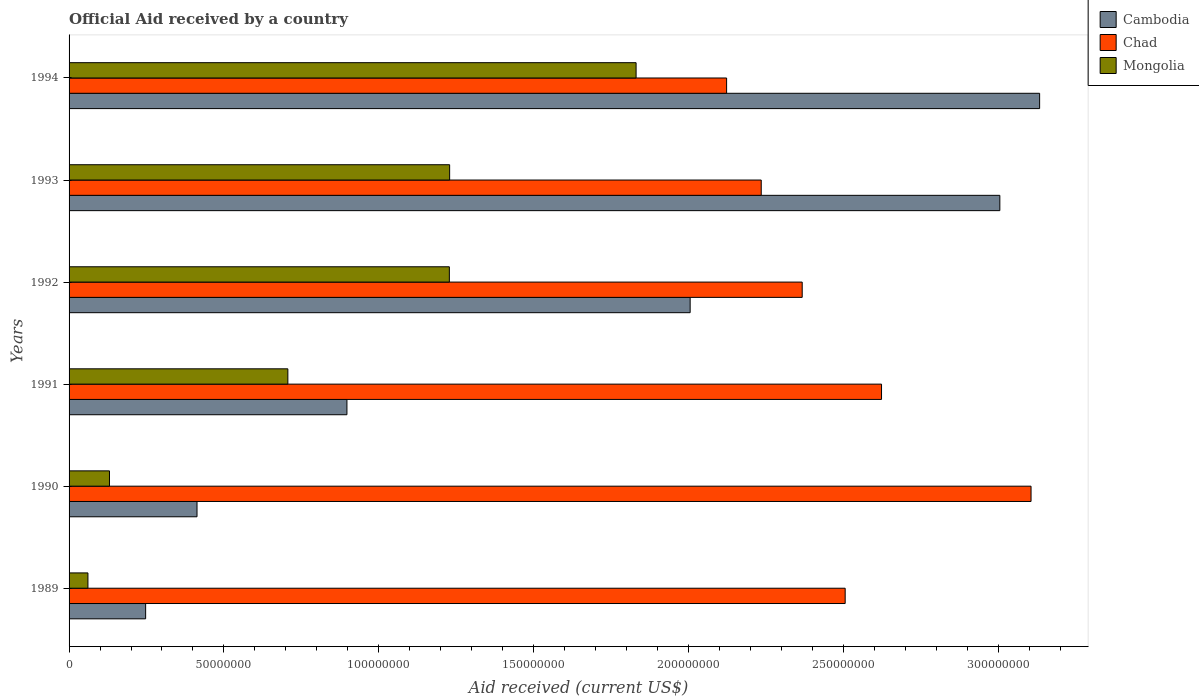How many different coloured bars are there?
Your answer should be very brief. 3. Are the number of bars per tick equal to the number of legend labels?
Keep it short and to the point. Yes. Are the number of bars on each tick of the Y-axis equal?
Make the answer very short. Yes. How many bars are there on the 1st tick from the bottom?
Your response must be concise. 3. What is the label of the 3rd group of bars from the top?
Make the answer very short. 1992. In how many cases, is the number of bars for a given year not equal to the number of legend labels?
Your answer should be compact. 0. What is the net official aid received in Cambodia in 1994?
Offer a terse response. 3.13e+08. Across all years, what is the maximum net official aid received in Cambodia?
Offer a very short reply. 3.13e+08. Across all years, what is the minimum net official aid received in Chad?
Provide a succinct answer. 2.12e+08. In which year was the net official aid received in Chad maximum?
Offer a terse response. 1990. What is the total net official aid received in Mongolia in the graph?
Your response must be concise. 5.18e+08. What is the difference between the net official aid received in Cambodia in 1991 and that in 1993?
Provide a short and direct response. -2.11e+08. What is the difference between the net official aid received in Mongolia in 1992 and the net official aid received in Cambodia in 1994?
Your response must be concise. -1.91e+08. What is the average net official aid received in Chad per year?
Ensure brevity in your answer.  2.49e+08. In the year 1990, what is the difference between the net official aid received in Chad and net official aid received in Mongolia?
Ensure brevity in your answer.  2.98e+08. In how many years, is the net official aid received in Chad greater than 70000000 US$?
Your answer should be compact. 6. What is the ratio of the net official aid received in Cambodia in 1990 to that in 1991?
Provide a short and direct response. 0.46. Is the difference between the net official aid received in Chad in 1989 and 1994 greater than the difference between the net official aid received in Mongolia in 1989 and 1994?
Provide a short and direct response. Yes. What is the difference between the highest and the second highest net official aid received in Mongolia?
Your answer should be very brief. 6.02e+07. What is the difference between the highest and the lowest net official aid received in Chad?
Your answer should be very brief. 9.83e+07. What does the 2nd bar from the top in 1992 represents?
Your response must be concise. Chad. What does the 1st bar from the bottom in 1991 represents?
Your answer should be very brief. Cambodia. Is it the case that in every year, the sum of the net official aid received in Mongolia and net official aid received in Cambodia is greater than the net official aid received in Chad?
Offer a terse response. No. How many years are there in the graph?
Offer a terse response. 6. What is the difference between two consecutive major ticks on the X-axis?
Your answer should be very brief. 5.00e+07. Are the values on the major ticks of X-axis written in scientific E-notation?
Give a very brief answer. No. Does the graph contain any zero values?
Make the answer very short. No. Does the graph contain grids?
Offer a terse response. No. What is the title of the graph?
Offer a terse response. Official Aid received by a country. What is the label or title of the X-axis?
Keep it short and to the point. Aid received (current US$). What is the Aid received (current US$) in Cambodia in 1989?
Offer a very short reply. 2.47e+07. What is the Aid received (current US$) of Chad in 1989?
Your answer should be compact. 2.51e+08. What is the Aid received (current US$) in Mongolia in 1989?
Provide a succinct answer. 6.09e+06. What is the Aid received (current US$) of Cambodia in 1990?
Give a very brief answer. 4.13e+07. What is the Aid received (current US$) of Chad in 1990?
Your response must be concise. 3.11e+08. What is the Aid received (current US$) of Mongolia in 1990?
Make the answer very short. 1.30e+07. What is the Aid received (current US$) of Cambodia in 1991?
Make the answer very short. 8.97e+07. What is the Aid received (current US$) of Chad in 1991?
Provide a succinct answer. 2.62e+08. What is the Aid received (current US$) in Mongolia in 1991?
Your answer should be very brief. 7.06e+07. What is the Aid received (current US$) in Cambodia in 1992?
Your response must be concise. 2.01e+08. What is the Aid received (current US$) in Chad in 1992?
Ensure brevity in your answer.  2.37e+08. What is the Aid received (current US$) in Mongolia in 1992?
Keep it short and to the point. 1.23e+08. What is the Aid received (current US$) of Cambodia in 1993?
Keep it short and to the point. 3.01e+08. What is the Aid received (current US$) of Chad in 1993?
Your response must be concise. 2.23e+08. What is the Aid received (current US$) of Mongolia in 1993?
Your answer should be very brief. 1.23e+08. What is the Aid received (current US$) in Cambodia in 1994?
Provide a short and direct response. 3.13e+08. What is the Aid received (current US$) of Chad in 1994?
Your answer should be compact. 2.12e+08. What is the Aid received (current US$) of Mongolia in 1994?
Make the answer very short. 1.83e+08. Across all years, what is the maximum Aid received (current US$) of Cambodia?
Keep it short and to the point. 3.13e+08. Across all years, what is the maximum Aid received (current US$) in Chad?
Offer a very short reply. 3.11e+08. Across all years, what is the maximum Aid received (current US$) in Mongolia?
Give a very brief answer. 1.83e+08. Across all years, what is the minimum Aid received (current US$) of Cambodia?
Give a very brief answer. 2.47e+07. Across all years, what is the minimum Aid received (current US$) of Chad?
Ensure brevity in your answer.  2.12e+08. Across all years, what is the minimum Aid received (current US$) of Mongolia?
Keep it short and to the point. 6.09e+06. What is the total Aid received (current US$) of Cambodia in the graph?
Offer a terse response. 9.70e+08. What is the total Aid received (current US$) in Chad in the graph?
Give a very brief answer. 1.50e+09. What is the total Aid received (current US$) in Mongolia in the graph?
Give a very brief answer. 5.18e+08. What is the difference between the Aid received (current US$) of Cambodia in 1989 and that in 1990?
Your answer should be compact. -1.66e+07. What is the difference between the Aid received (current US$) of Chad in 1989 and that in 1990?
Give a very brief answer. -6.00e+07. What is the difference between the Aid received (current US$) of Mongolia in 1989 and that in 1990?
Give a very brief answer. -6.96e+06. What is the difference between the Aid received (current US$) of Cambodia in 1989 and that in 1991?
Offer a very short reply. -6.50e+07. What is the difference between the Aid received (current US$) of Chad in 1989 and that in 1991?
Make the answer very short. -1.17e+07. What is the difference between the Aid received (current US$) in Mongolia in 1989 and that in 1991?
Provide a succinct answer. -6.46e+07. What is the difference between the Aid received (current US$) in Cambodia in 1989 and that in 1992?
Your response must be concise. -1.76e+08. What is the difference between the Aid received (current US$) of Chad in 1989 and that in 1992?
Your response must be concise. 1.39e+07. What is the difference between the Aid received (current US$) of Mongolia in 1989 and that in 1992?
Offer a very short reply. -1.17e+08. What is the difference between the Aid received (current US$) of Cambodia in 1989 and that in 1993?
Keep it short and to the point. -2.76e+08. What is the difference between the Aid received (current US$) of Chad in 1989 and that in 1993?
Your response must be concise. 2.71e+07. What is the difference between the Aid received (current US$) in Mongolia in 1989 and that in 1993?
Give a very brief answer. -1.17e+08. What is the difference between the Aid received (current US$) of Cambodia in 1989 and that in 1994?
Your answer should be very brief. -2.89e+08. What is the difference between the Aid received (current US$) of Chad in 1989 and that in 1994?
Keep it short and to the point. 3.83e+07. What is the difference between the Aid received (current US$) of Mongolia in 1989 and that in 1994?
Offer a very short reply. -1.77e+08. What is the difference between the Aid received (current US$) in Cambodia in 1990 and that in 1991?
Keep it short and to the point. -4.84e+07. What is the difference between the Aid received (current US$) of Chad in 1990 and that in 1991?
Provide a succinct answer. 4.83e+07. What is the difference between the Aid received (current US$) of Mongolia in 1990 and that in 1991?
Keep it short and to the point. -5.76e+07. What is the difference between the Aid received (current US$) of Cambodia in 1990 and that in 1992?
Ensure brevity in your answer.  -1.59e+08. What is the difference between the Aid received (current US$) of Chad in 1990 and that in 1992?
Offer a terse response. 7.39e+07. What is the difference between the Aid received (current US$) of Mongolia in 1990 and that in 1992?
Offer a terse response. -1.10e+08. What is the difference between the Aid received (current US$) of Cambodia in 1990 and that in 1993?
Offer a terse response. -2.59e+08. What is the difference between the Aid received (current US$) of Chad in 1990 and that in 1993?
Keep it short and to the point. 8.71e+07. What is the difference between the Aid received (current US$) of Mongolia in 1990 and that in 1993?
Provide a succinct answer. -1.10e+08. What is the difference between the Aid received (current US$) in Cambodia in 1990 and that in 1994?
Offer a very short reply. -2.72e+08. What is the difference between the Aid received (current US$) of Chad in 1990 and that in 1994?
Your response must be concise. 9.83e+07. What is the difference between the Aid received (current US$) of Mongolia in 1990 and that in 1994?
Make the answer very short. -1.70e+08. What is the difference between the Aid received (current US$) of Cambodia in 1991 and that in 1992?
Your answer should be very brief. -1.11e+08. What is the difference between the Aid received (current US$) of Chad in 1991 and that in 1992?
Keep it short and to the point. 2.56e+07. What is the difference between the Aid received (current US$) in Mongolia in 1991 and that in 1992?
Your response must be concise. -5.21e+07. What is the difference between the Aid received (current US$) in Cambodia in 1991 and that in 1993?
Your answer should be very brief. -2.11e+08. What is the difference between the Aid received (current US$) of Chad in 1991 and that in 1993?
Ensure brevity in your answer.  3.88e+07. What is the difference between the Aid received (current US$) in Mongolia in 1991 and that in 1993?
Ensure brevity in your answer.  -5.22e+07. What is the difference between the Aid received (current US$) of Cambodia in 1991 and that in 1994?
Make the answer very short. -2.24e+08. What is the difference between the Aid received (current US$) in Chad in 1991 and that in 1994?
Ensure brevity in your answer.  5.00e+07. What is the difference between the Aid received (current US$) in Mongolia in 1991 and that in 1994?
Your answer should be very brief. -1.12e+08. What is the difference between the Aid received (current US$) in Cambodia in 1992 and that in 1993?
Give a very brief answer. -1.00e+08. What is the difference between the Aid received (current US$) in Chad in 1992 and that in 1993?
Provide a short and direct response. 1.32e+07. What is the difference between the Aid received (current US$) in Cambodia in 1992 and that in 1994?
Your response must be concise. -1.13e+08. What is the difference between the Aid received (current US$) of Chad in 1992 and that in 1994?
Ensure brevity in your answer.  2.44e+07. What is the difference between the Aid received (current US$) of Mongolia in 1992 and that in 1994?
Give a very brief answer. -6.03e+07. What is the difference between the Aid received (current US$) in Cambodia in 1993 and that in 1994?
Ensure brevity in your answer.  -1.28e+07. What is the difference between the Aid received (current US$) of Chad in 1993 and that in 1994?
Offer a terse response. 1.12e+07. What is the difference between the Aid received (current US$) of Mongolia in 1993 and that in 1994?
Your response must be concise. -6.02e+07. What is the difference between the Aid received (current US$) of Cambodia in 1989 and the Aid received (current US$) of Chad in 1990?
Offer a terse response. -2.86e+08. What is the difference between the Aid received (current US$) of Cambodia in 1989 and the Aid received (current US$) of Mongolia in 1990?
Provide a succinct answer. 1.17e+07. What is the difference between the Aid received (current US$) of Chad in 1989 and the Aid received (current US$) of Mongolia in 1990?
Keep it short and to the point. 2.38e+08. What is the difference between the Aid received (current US$) of Cambodia in 1989 and the Aid received (current US$) of Chad in 1991?
Ensure brevity in your answer.  -2.38e+08. What is the difference between the Aid received (current US$) of Cambodia in 1989 and the Aid received (current US$) of Mongolia in 1991?
Your answer should be very brief. -4.59e+07. What is the difference between the Aid received (current US$) of Chad in 1989 and the Aid received (current US$) of Mongolia in 1991?
Offer a terse response. 1.80e+08. What is the difference between the Aid received (current US$) in Cambodia in 1989 and the Aid received (current US$) in Chad in 1992?
Your response must be concise. -2.12e+08. What is the difference between the Aid received (current US$) in Cambodia in 1989 and the Aid received (current US$) in Mongolia in 1992?
Your answer should be compact. -9.81e+07. What is the difference between the Aid received (current US$) of Chad in 1989 and the Aid received (current US$) of Mongolia in 1992?
Make the answer very short. 1.28e+08. What is the difference between the Aid received (current US$) of Cambodia in 1989 and the Aid received (current US$) of Chad in 1993?
Keep it short and to the point. -1.99e+08. What is the difference between the Aid received (current US$) in Cambodia in 1989 and the Aid received (current US$) in Mongolia in 1993?
Ensure brevity in your answer.  -9.82e+07. What is the difference between the Aid received (current US$) in Chad in 1989 and the Aid received (current US$) in Mongolia in 1993?
Make the answer very short. 1.28e+08. What is the difference between the Aid received (current US$) in Cambodia in 1989 and the Aid received (current US$) in Chad in 1994?
Make the answer very short. -1.88e+08. What is the difference between the Aid received (current US$) of Cambodia in 1989 and the Aid received (current US$) of Mongolia in 1994?
Keep it short and to the point. -1.58e+08. What is the difference between the Aid received (current US$) of Chad in 1989 and the Aid received (current US$) of Mongolia in 1994?
Give a very brief answer. 6.75e+07. What is the difference between the Aid received (current US$) in Cambodia in 1990 and the Aid received (current US$) in Chad in 1991?
Your response must be concise. -2.21e+08. What is the difference between the Aid received (current US$) of Cambodia in 1990 and the Aid received (current US$) of Mongolia in 1991?
Make the answer very short. -2.93e+07. What is the difference between the Aid received (current US$) in Chad in 1990 and the Aid received (current US$) in Mongolia in 1991?
Keep it short and to the point. 2.40e+08. What is the difference between the Aid received (current US$) of Cambodia in 1990 and the Aid received (current US$) of Chad in 1992?
Keep it short and to the point. -1.95e+08. What is the difference between the Aid received (current US$) of Cambodia in 1990 and the Aid received (current US$) of Mongolia in 1992?
Ensure brevity in your answer.  -8.15e+07. What is the difference between the Aid received (current US$) of Chad in 1990 and the Aid received (current US$) of Mongolia in 1992?
Offer a very short reply. 1.88e+08. What is the difference between the Aid received (current US$) of Cambodia in 1990 and the Aid received (current US$) of Chad in 1993?
Ensure brevity in your answer.  -1.82e+08. What is the difference between the Aid received (current US$) in Cambodia in 1990 and the Aid received (current US$) in Mongolia in 1993?
Offer a very short reply. -8.16e+07. What is the difference between the Aid received (current US$) of Chad in 1990 and the Aid received (current US$) of Mongolia in 1993?
Offer a terse response. 1.88e+08. What is the difference between the Aid received (current US$) in Cambodia in 1990 and the Aid received (current US$) in Chad in 1994?
Give a very brief answer. -1.71e+08. What is the difference between the Aid received (current US$) in Cambodia in 1990 and the Aid received (current US$) in Mongolia in 1994?
Give a very brief answer. -1.42e+08. What is the difference between the Aid received (current US$) of Chad in 1990 and the Aid received (current US$) of Mongolia in 1994?
Your answer should be compact. 1.28e+08. What is the difference between the Aid received (current US$) in Cambodia in 1991 and the Aid received (current US$) in Chad in 1992?
Make the answer very short. -1.47e+08. What is the difference between the Aid received (current US$) of Cambodia in 1991 and the Aid received (current US$) of Mongolia in 1992?
Give a very brief answer. -3.31e+07. What is the difference between the Aid received (current US$) of Chad in 1991 and the Aid received (current US$) of Mongolia in 1992?
Give a very brief answer. 1.40e+08. What is the difference between the Aid received (current US$) in Cambodia in 1991 and the Aid received (current US$) in Chad in 1993?
Give a very brief answer. -1.34e+08. What is the difference between the Aid received (current US$) of Cambodia in 1991 and the Aid received (current US$) of Mongolia in 1993?
Your answer should be very brief. -3.32e+07. What is the difference between the Aid received (current US$) in Chad in 1991 and the Aid received (current US$) in Mongolia in 1993?
Keep it short and to the point. 1.39e+08. What is the difference between the Aid received (current US$) in Cambodia in 1991 and the Aid received (current US$) in Chad in 1994?
Provide a short and direct response. -1.23e+08. What is the difference between the Aid received (current US$) in Cambodia in 1991 and the Aid received (current US$) in Mongolia in 1994?
Provide a succinct answer. -9.34e+07. What is the difference between the Aid received (current US$) in Chad in 1991 and the Aid received (current US$) in Mongolia in 1994?
Keep it short and to the point. 7.92e+07. What is the difference between the Aid received (current US$) in Cambodia in 1992 and the Aid received (current US$) in Chad in 1993?
Offer a very short reply. -2.30e+07. What is the difference between the Aid received (current US$) in Cambodia in 1992 and the Aid received (current US$) in Mongolia in 1993?
Your response must be concise. 7.76e+07. What is the difference between the Aid received (current US$) in Chad in 1992 and the Aid received (current US$) in Mongolia in 1993?
Your answer should be compact. 1.14e+08. What is the difference between the Aid received (current US$) in Cambodia in 1992 and the Aid received (current US$) in Chad in 1994?
Give a very brief answer. -1.18e+07. What is the difference between the Aid received (current US$) of Cambodia in 1992 and the Aid received (current US$) of Mongolia in 1994?
Your response must be concise. 1.74e+07. What is the difference between the Aid received (current US$) in Chad in 1992 and the Aid received (current US$) in Mongolia in 1994?
Provide a short and direct response. 5.36e+07. What is the difference between the Aid received (current US$) in Cambodia in 1993 and the Aid received (current US$) in Chad in 1994?
Your response must be concise. 8.82e+07. What is the difference between the Aid received (current US$) of Cambodia in 1993 and the Aid received (current US$) of Mongolia in 1994?
Ensure brevity in your answer.  1.17e+08. What is the difference between the Aid received (current US$) of Chad in 1993 and the Aid received (current US$) of Mongolia in 1994?
Offer a very short reply. 4.04e+07. What is the average Aid received (current US$) in Cambodia per year?
Your answer should be compact. 1.62e+08. What is the average Aid received (current US$) of Chad per year?
Make the answer very short. 2.49e+08. What is the average Aid received (current US$) in Mongolia per year?
Your answer should be compact. 8.64e+07. In the year 1989, what is the difference between the Aid received (current US$) in Cambodia and Aid received (current US$) in Chad?
Offer a terse response. -2.26e+08. In the year 1989, what is the difference between the Aid received (current US$) in Cambodia and Aid received (current US$) in Mongolia?
Offer a terse response. 1.86e+07. In the year 1989, what is the difference between the Aid received (current US$) in Chad and Aid received (current US$) in Mongolia?
Your response must be concise. 2.44e+08. In the year 1990, what is the difference between the Aid received (current US$) in Cambodia and Aid received (current US$) in Chad?
Offer a very short reply. -2.69e+08. In the year 1990, what is the difference between the Aid received (current US$) in Cambodia and Aid received (current US$) in Mongolia?
Your answer should be compact. 2.83e+07. In the year 1990, what is the difference between the Aid received (current US$) in Chad and Aid received (current US$) in Mongolia?
Provide a short and direct response. 2.98e+08. In the year 1991, what is the difference between the Aid received (current US$) in Cambodia and Aid received (current US$) in Chad?
Your answer should be very brief. -1.73e+08. In the year 1991, what is the difference between the Aid received (current US$) of Cambodia and Aid received (current US$) of Mongolia?
Give a very brief answer. 1.91e+07. In the year 1991, what is the difference between the Aid received (current US$) in Chad and Aid received (current US$) in Mongolia?
Make the answer very short. 1.92e+08. In the year 1992, what is the difference between the Aid received (current US$) of Cambodia and Aid received (current US$) of Chad?
Offer a very short reply. -3.62e+07. In the year 1992, what is the difference between the Aid received (current US$) of Cambodia and Aid received (current US$) of Mongolia?
Offer a very short reply. 7.77e+07. In the year 1992, what is the difference between the Aid received (current US$) of Chad and Aid received (current US$) of Mongolia?
Offer a terse response. 1.14e+08. In the year 1993, what is the difference between the Aid received (current US$) of Cambodia and Aid received (current US$) of Chad?
Make the answer very short. 7.70e+07. In the year 1993, what is the difference between the Aid received (current US$) in Cambodia and Aid received (current US$) in Mongolia?
Offer a terse response. 1.78e+08. In the year 1993, what is the difference between the Aid received (current US$) of Chad and Aid received (current US$) of Mongolia?
Your answer should be very brief. 1.01e+08. In the year 1994, what is the difference between the Aid received (current US$) in Cambodia and Aid received (current US$) in Chad?
Ensure brevity in your answer.  1.01e+08. In the year 1994, what is the difference between the Aid received (current US$) of Cambodia and Aid received (current US$) of Mongolia?
Provide a succinct answer. 1.30e+08. In the year 1994, what is the difference between the Aid received (current US$) in Chad and Aid received (current US$) in Mongolia?
Make the answer very short. 2.92e+07. What is the ratio of the Aid received (current US$) in Cambodia in 1989 to that in 1990?
Keep it short and to the point. 0.6. What is the ratio of the Aid received (current US$) in Chad in 1989 to that in 1990?
Ensure brevity in your answer.  0.81. What is the ratio of the Aid received (current US$) of Mongolia in 1989 to that in 1990?
Give a very brief answer. 0.47. What is the ratio of the Aid received (current US$) of Cambodia in 1989 to that in 1991?
Provide a short and direct response. 0.28. What is the ratio of the Aid received (current US$) in Chad in 1989 to that in 1991?
Offer a very short reply. 0.96. What is the ratio of the Aid received (current US$) of Mongolia in 1989 to that in 1991?
Provide a succinct answer. 0.09. What is the ratio of the Aid received (current US$) of Cambodia in 1989 to that in 1992?
Keep it short and to the point. 0.12. What is the ratio of the Aid received (current US$) of Chad in 1989 to that in 1992?
Your response must be concise. 1.06. What is the ratio of the Aid received (current US$) in Mongolia in 1989 to that in 1992?
Give a very brief answer. 0.05. What is the ratio of the Aid received (current US$) in Cambodia in 1989 to that in 1993?
Offer a very short reply. 0.08. What is the ratio of the Aid received (current US$) of Chad in 1989 to that in 1993?
Offer a terse response. 1.12. What is the ratio of the Aid received (current US$) in Mongolia in 1989 to that in 1993?
Your response must be concise. 0.05. What is the ratio of the Aid received (current US$) of Cambodia in 1989 to that in 1994?
Offer a terse response. 0.08. What is the ratio of the Aid received (current US$) of Chad in 1989 to that in 1994?
Make the answer very short. 1.18. What is the ratio of the Aid received (current US$) in Cambodia in 1990 to that in 1991?
Provide a succinct answer. 0.46. What is the ratio of the Aid received (current US$) in Chad in 1990 to that in 1991?
Provide a short and direct response. 1.18. What is the ratio of the Aid received (current US$) in Mongolia in 1990 to that in 1991?
Ensure brevity in your answer.  0.18. What is the ratio of the Aid received (current US$) in Cambodia in 1990 to that in 1992?
Your response must be concise. 0.21. What is the ratio of the Aid received (current US$) in Chad in 1990 to that in 1992?
Your answer should be compact. 1.31. What is the ratio of the Aid received (current US$) of Mongolia in 1990 to that in 1992?
Offer a terse response. 0.11. What is the ratio of the Aid received (current US$) of Cambodia in 1990 to that in 1993?
Give a very brief answer. 0.14. What is the ratio of the Aid received (current US$) of Chad in 1990 to that in 1993?
Provide a short and direct response. 1.39. What is the ratio of the Aid received (current US$) of Mongolia in 1990 to that in 1993?
Ensure brevity in your answer.  0.11. What is the ratio of the Aid received (current US$) of Cambodia in 1990 to that in 1994?
Provide a succinct answer. 0.13. What is the ratio of the Aid received (current US$) of Chad in 1990 to that in 1994?
Make the answer very short. 1.46. What is the ratio of the Aid received (current US$) in Mongolia in 1990 to that in 1994?
Offer a terse response. 0.07. What is the ratio of the Aid received (current US$) in Cambodia in 1991 to that in 1992?
Provide a succinct answer. 0.45. What is the ratio of the Aid received (current US$) of Chad in 1991 to that in 1992?
Make the answer very short. 1.11. What is the ratio of the Aid received (current US$) of Mongolia in 1991 to that in 1992?
Offer a very short reply. 0.58. What is the ratio of the Aid received (current US$) in Cambodia in 1991 to that in 1993?
Offer a very short reply. 0.3. What is the ratio of the Aid received (current US$) of Chad in 1991 to that in 1993?
Your response must be concise. 1.17. What is the ratio of the Aid received (current US$) in Mongolia in 1991 to that in 1993?
Your response must be concise. 0.57. What is the ratio of the Aid received (current US$) of Cambodia in 1991 to that in 1994?
Your response must be concise. 0.29. What is the ratio of the Aid received (current US$) of Chad in 1991 to that in 1994?
Your response must be concise. 1.24. What is the ratio of the Aid received (current US$) in Mongolia in 1991 to that in 1994?
Give a very brief answer. 0.39. What is the ratio of the Aid received (current US$) of Cambodia in 1992 to that in 1993?
Your answer should be very brief. 0.67. What is the ratio of the Aid received (current US$) in Chad in 1992 to that in 1993?
Provide a short and direct response. 1.06. What is the ratio of the Aid received (current US$) of Mongolia in 1992 to that in 1993?
Your response must be concise. 1. What is the ratio of the Aid received (current US$) in Cambodia in 1992 to that in 1994?
Make the answer very short. 0.64. What is the ratio of the Aid received (current US$) in Chad in 1992 to that in 1994?
Offer a terse response. 1.11. What is the ratio of the Aid received (current US$) in Mongolia in 1992 to that in 1994?
Keep it short and to the point. 0.67. What is the ratio of the Aid received (current US$) in Cambodia in 1993 to that in 1994?
Offer a terse response. 0.96. What is the ratio of the Aid received (current US$) of Chad in 1993 to that in 1994?
Your answer should be compact. 1.05. What is the ratio of the Aid received (current US$) in Mongolia in 1993 to that in 1994?
Your response must be concise. 0.67. What is the difference between the highest and the second highest Aid received (current US$) in Cambodia?
Provide a succinct answer. 1.28e+07. What is the difference between the highest and the second highest Aid received (current US$) of Chad?
Give a very brief answer. 4.83e+07. What is the difference between the highest and the second highest Aid received (current US$) of Mongolia?
Your response must be concise. 6.02e+07. What is the difference between the highest and the lowest Aid received (current US$) of Cambodia?
Provide a succinct answer. 2.89e+08. What is the difference between the highest and the lowest Aid received (current US$) in Chad?
Your answer should be very brief. 9.83e+07. What is the difference between the highest and the lowest Aid received (current US$) of Mongolia?
Offer a very short reply. 1.77e+08. 